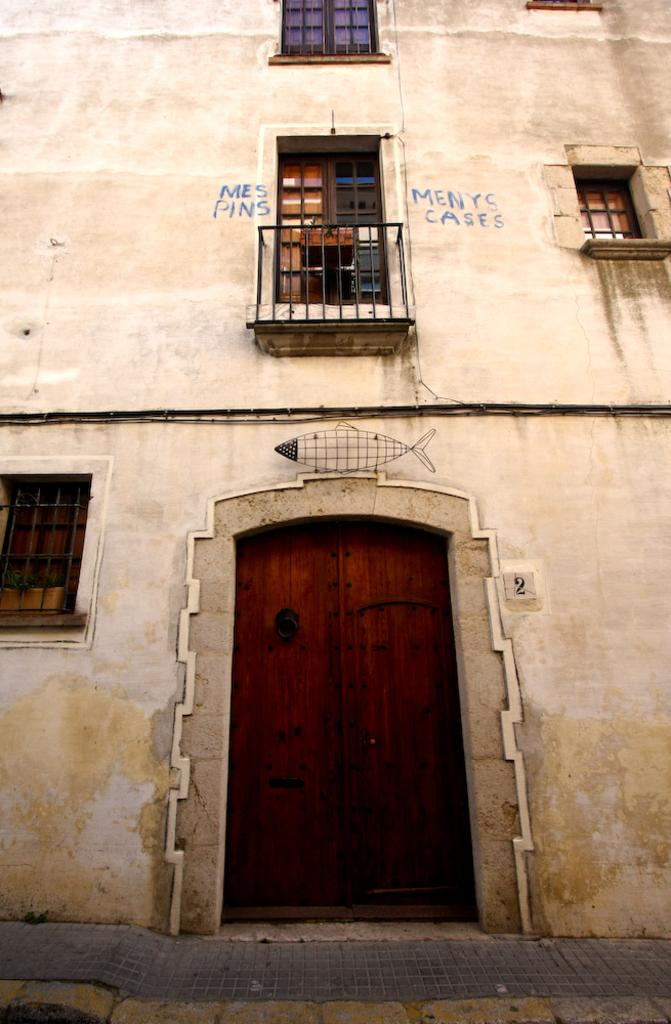What type of structure is present in the image? There is a building in the image. What features can be seen on the building? The building has a door and windows. What type of hat is hanging on the door of the building in the image? There is no hat present on the door of the building in the image. Are there any beds visible inside the building in the image? The image does not show the interior of the building, so it is impossible to determine if there are any beds inside. 